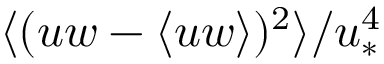<formula> <loc_0><loc_0><loc_500><loc_500>\langle ( u w - \langle u w \rangle ) ^ { 2 } \rangle / u _ { \ast } ^ { 4 }</formula> 